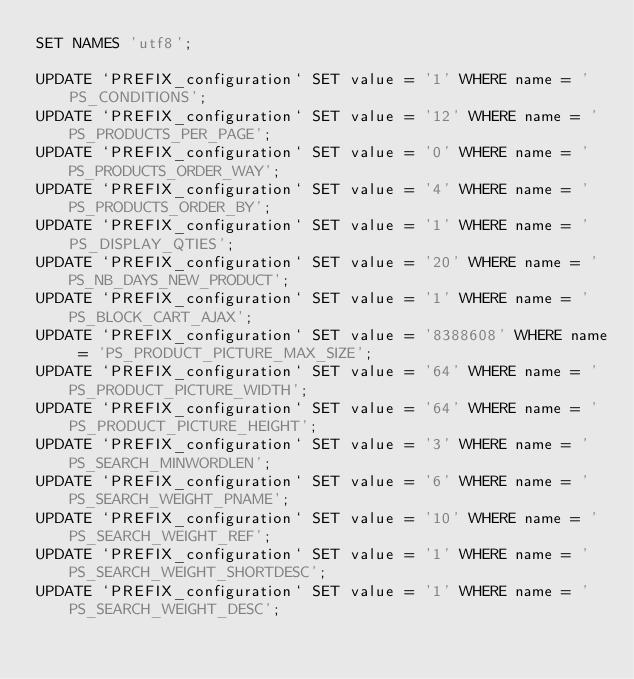Convert code to text. <code><loc_0><loc_0><loc_500><loc_500><_SQL_>SET NAMES 'utf8';

UPDATE `PREFIX_configuration` SET value = '1' WHERE name = 'PS_CONDITIONS';
UPDATE `PREFIX_configuration` SET value = '12' WHERE name = 'PS_PRODUCTS_PER_PAGE';
UPDATE `PREFIX_configuration` SET value = '0' WHERE name = 'PS_PRODUCTS_ORDER_WAY';
UPDATE `PREFIX_configuration` SET value = '4' WHERE name = 'PS_PRODUCTS_ORDER_BY';
UPDATE `PREFIX_configuration` SET value = '1' WHERE name = 'PS_DISPLAY_QTIES';
UPDATE `PREFIX_configuration` SET value = '20' WHERE name = 'PS_NB_DAYS_NEW_PRODUCT';
UPDATE `PREFIX_configuration` SET value = '1' WHERE name = 'PS_BLOCK_CART_AJAX';
UPDATE `PREFIX_configuration` SET value = '8388608' WHERE name = 'PS_PRODUCT_PICTURE_MAX_SIZE';
UPDATE `PREFIX_configuration` SET value = '64' WHERE name = 'PS_PRODUCT_PICTURE_WIDTH';
UPDATE `PREFIX_configuration` SET value = '64' WHERE name = 'PS_PRODUCT_PICTURE_HEIGHT';
UPDATE `PREFIX_configuration` SET value = '3' WHERE name = 'PS_SEARCH_MINWORDLEN';
UPDATE `PREFIX_configuration` SET value = '6' WHERE name = 'PS_SEARCH_WEIGHT_PNAME';
UPDATE `PREFIX_configuration` SET value = '10' WHERE name = 'PS_SEARCH_WEIGHT_REF';
UPDATE `PREFIX_configuration` SET value = '1' WHERE name = 'PS_SEARCH_WEIGHT_SHORTDESC';
UPDATE `PREFIX_configuration` SET value = '1' WHERE name = 'PS_SEARCH_WEIGHT_DESC';</code> 